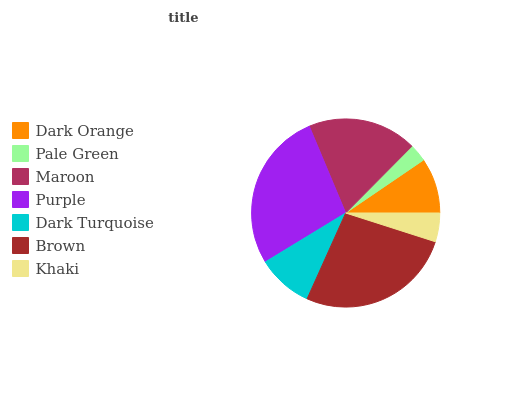Is Pale Green the minimum?
Answer yes or no. Yes. Is Purple the maximum?
Answer yes or no. Yes. Is Maroon the minimum?
Answer yes or no. No. Is Maroon the maximum?
Answer yes or no. No. Is Maroon greater than Pale Green?
Answer yes or no. Yes. Is Pale Green less than Maroon?
Answer yes or no. Yes. Is Pale Green greater than Maroon?
Answer yes or no. No. Is Maroon less than Pale Green?
Answer yes or no. No. Is Dark Turquoise the high median?
Answer yes or no. Yes. Is Dark Turquoise the low median?
Answer yes or no. Yes. Is Khaki the high median?
Answer yes or no. No. Is Khaki the low median?
Answer yes or no. No. 